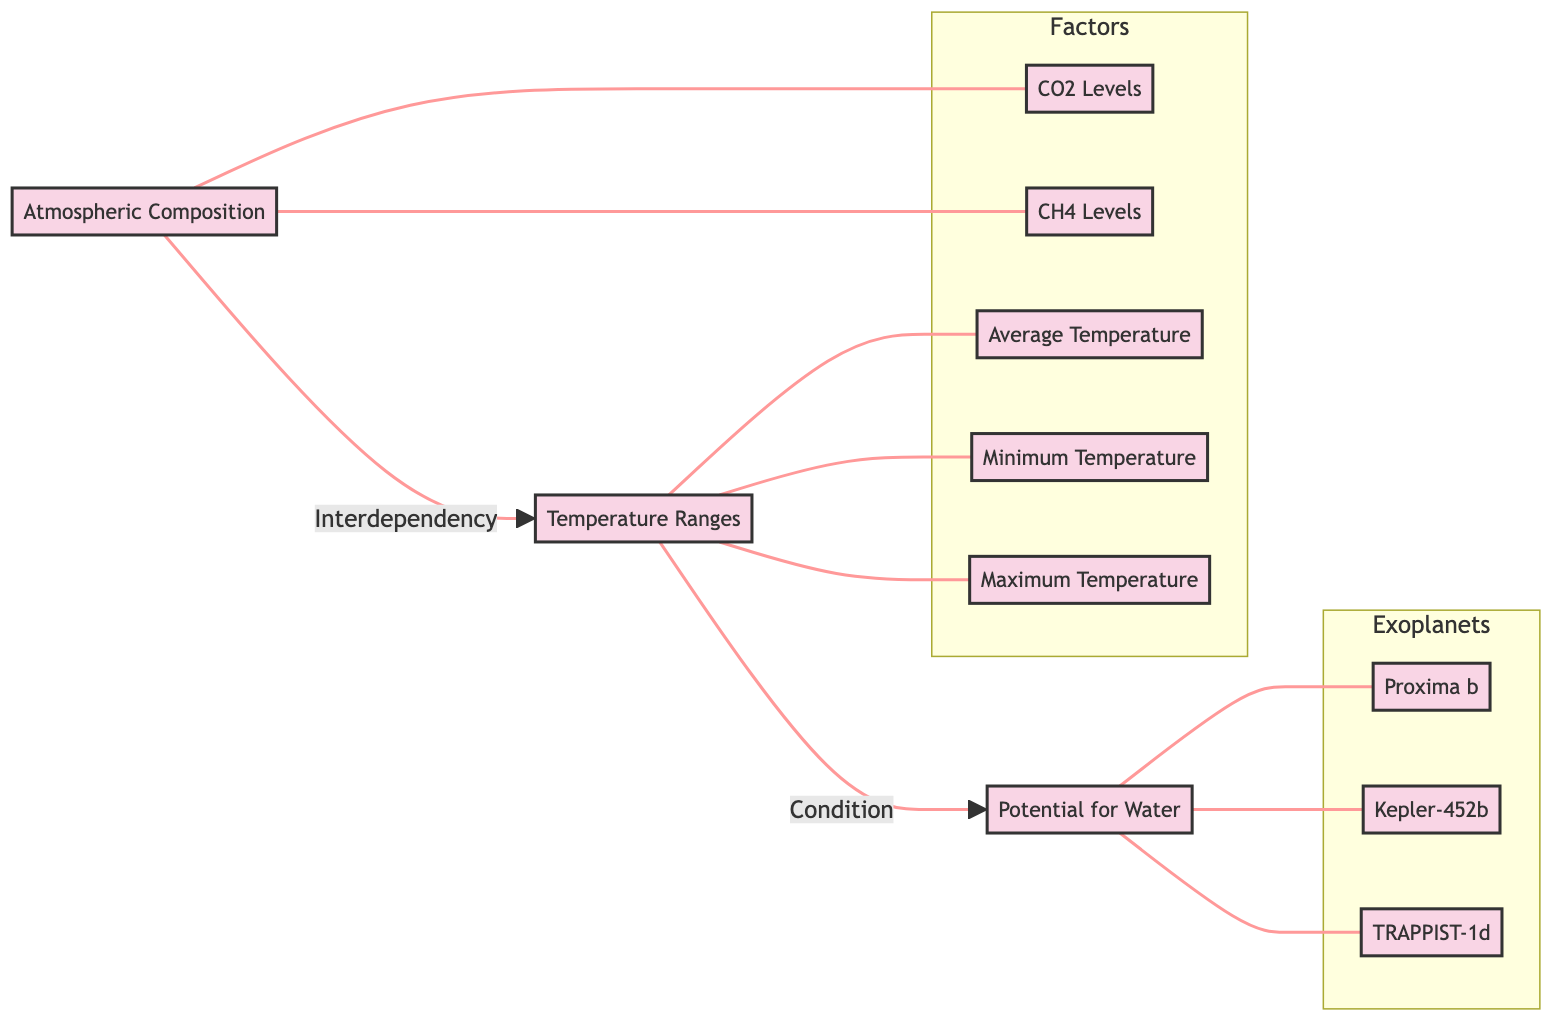What is the main focus of the diagram? The diagram reviews the habitability criteria of exoplanets, specifically analyzing atmospheric composition, temperature ranges, and the potential for water presence.
Answer: Exoplanet Habitability Criteria How many factors are illustrated in the diagram? The diagram displays three main factors, represented by the nodes for Atmospheric Composition, Temperature Ranges, and Potential for Water.
Answer: 3 What does the arrow from Atmospheric Composition to Temperature Ranges signify? The arrow indicates an interdependency relationship, suggesting that atmospheric composition affects temperature ranges of the exoplanets.
Answer: Interdependency What is the minimum temperature for the exoplanet Proxima b? The diagram does not explicitly show the minimum temperature for Proxima b, requiring reference to additional data to provide a value.
Answer: Not specified Which exoplanet is linked to the potential for water according to the diagram? The diagram connects all three listed exoplanets (Proxima b, Kepler-452b, TRAPPIST-1d) to the node representing Potential for Water.
Answer: Proxima b, Kepler-452b, TRAPPIST-1d Explain the relationship between Temperature Ranges and Potential for Water. The diagram shows a directional relationship from Temperature Ranges to Potential for Water, indicating that the temperature conditions on an exoplanet influence its ability to maintain water. This implies that viable temperature ranges are a prerequisite for water presence.
Answer: Temperature conditions influence water presence What does the 'subgraph Factors' consist of? The subgraph labeled Factors includes four specific components: CO2 Levels, CH4 Levels, Average Temperature, Minimum Temperature, and Maximum Temperature.
Answer: CO2 Levels, CH4 Levels, Average Temperature, Minimum Temperature, Maximum Temperature How does the diagram represent the relationship between exoplanets and atmospheric factors? The diagram uses connecting lines to link exoplanets Proxima b, Kepler-452b, and TRAPPIST-1d with Atmospheric Composition factors, showing that their habitability assessments involve these atmospheric variables.
Answer: Connecting lines indicate relationships What type of diagram is this? This is a flowchart diagram that visually represents interdependencies and relationships among various factors influencing exoplanet habitability.
Answer: Flowchart 